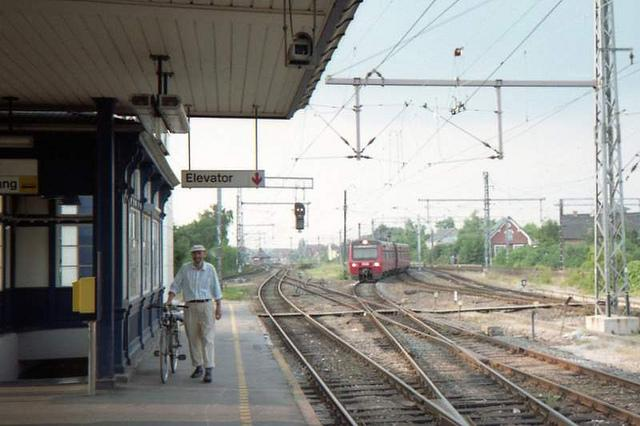What is the object hanging underneath the roof eave?

Choices:
A) signal light
B) flood light
C) camera
D) speaker camera 